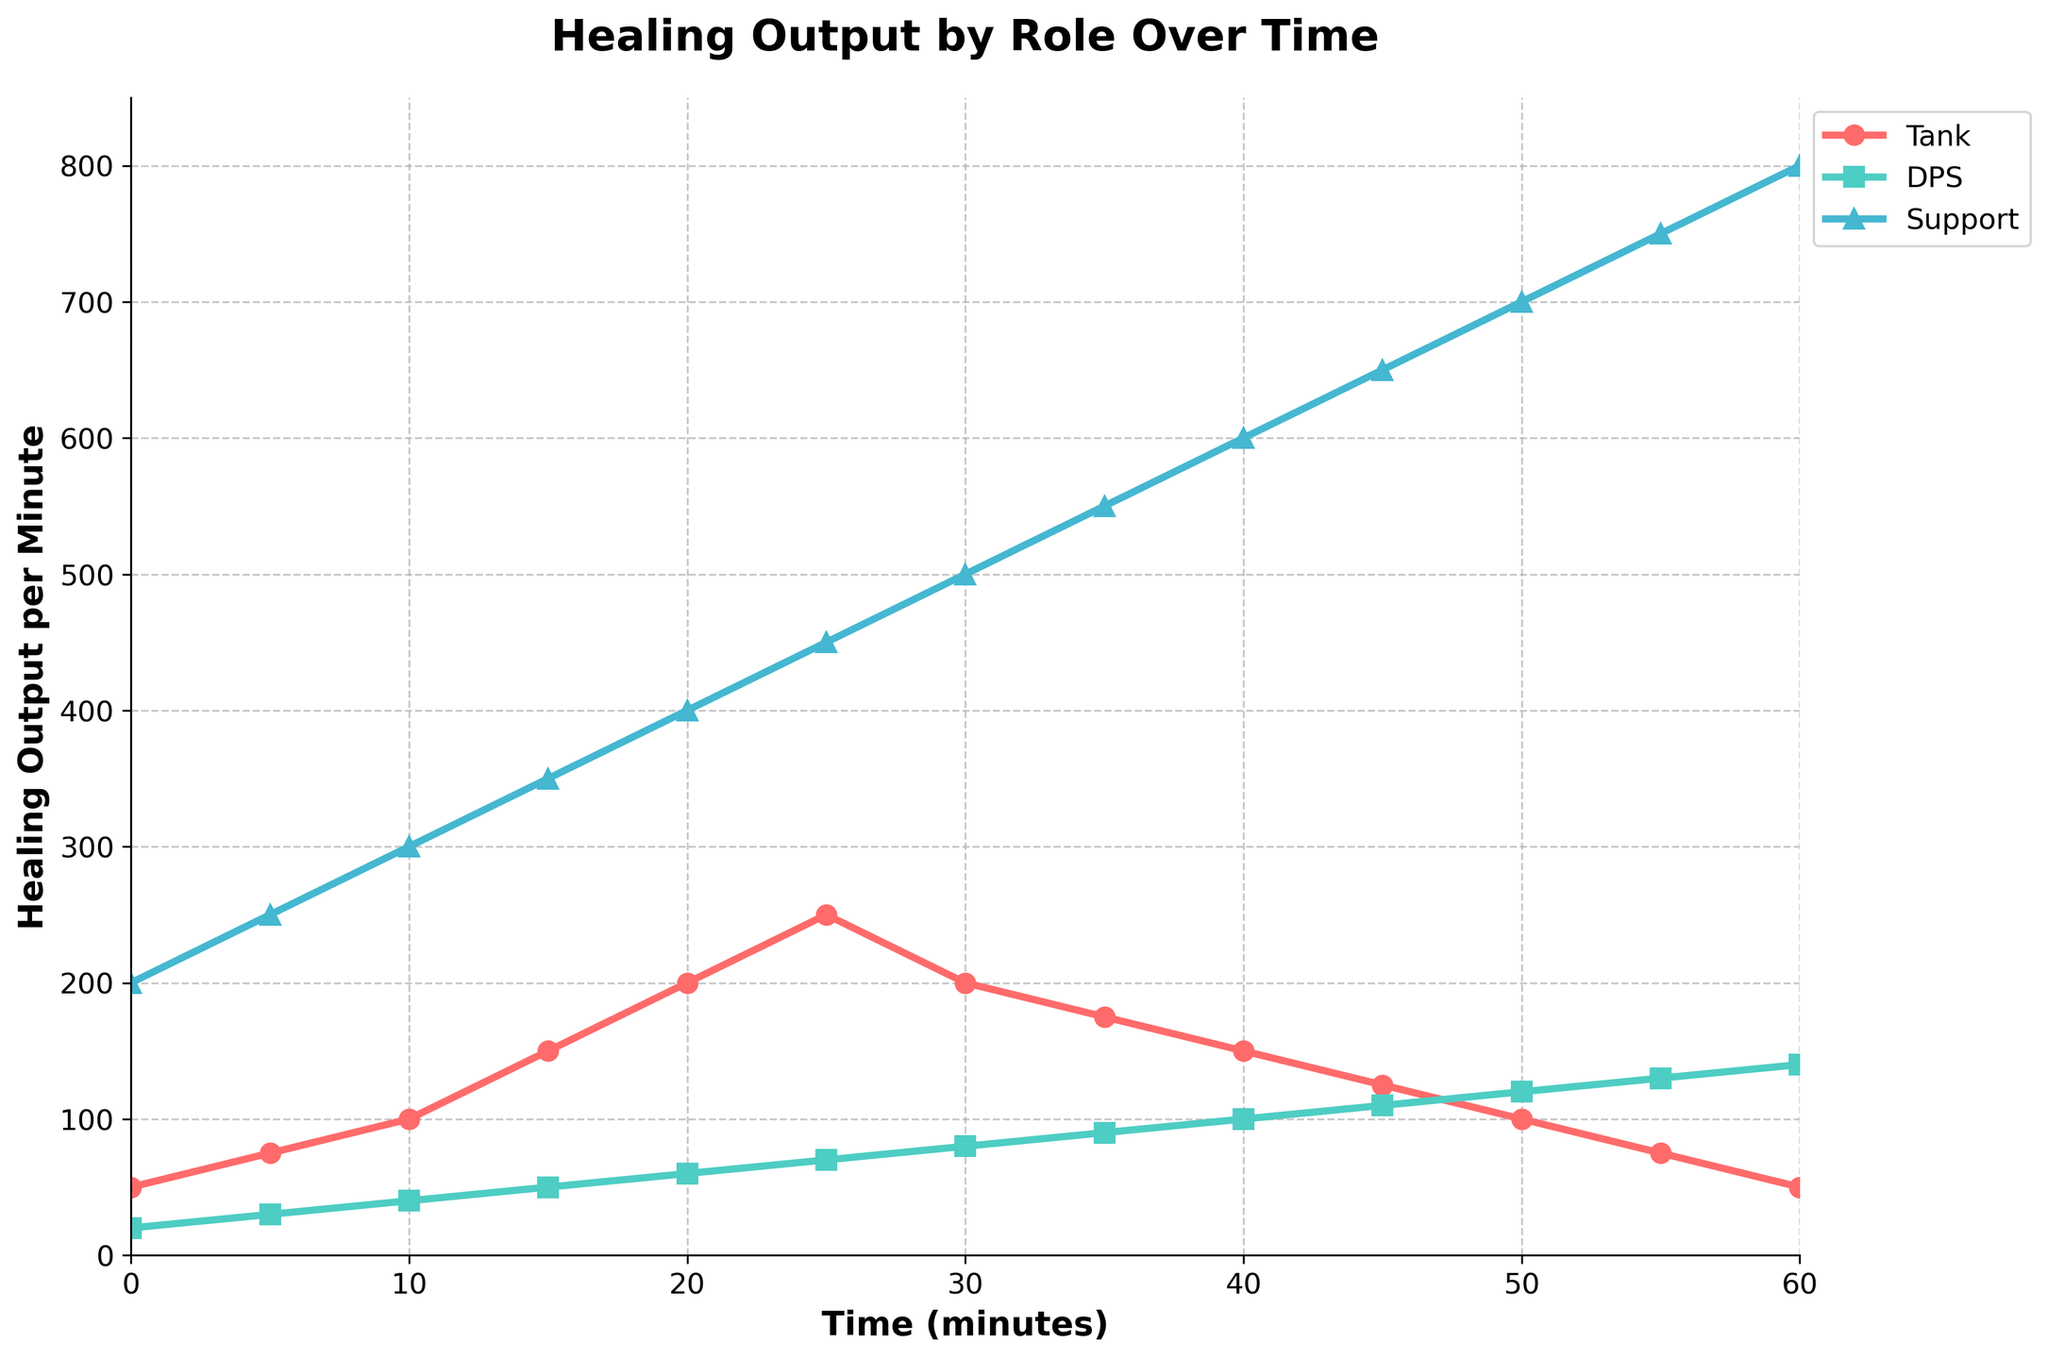How does the healing output of the Tank role change over time? The healing output of the Tank role increases from 50 at the start to a peak of 250 at 25 minutes, then decreases back to 50 by the end of the match.
Answer: It increases, peaks, then decreases Which role has the highest healing output at the 30-minute mark? At the 30-minute mark, the Support role has a healing output of 500, which is higher than both the Tank (200) and DPS (80) roles.
Answer: Support What is the difference in healing output between the Support and Tank roles at the 60-minute mark? At the 60-minute mark, the healing output for Support is 800 and for Tank is 50. The difference is 800 - 50.
Answer: 750 What is the average healing output of the DPS role from 0 to 60 minutes? The healing outputs for the DPS role at each time point are 20, 30, 40, 50, 60, 70, 80, 90, 100, 110, 120, 130, 140. Summing these gives 1040, and there are 13 points. Thus, 1040 / 13.
Answer: 80 How does the healing output for the DPS role compare to the Tank role at the 45-minute mark? At the 45-minute mark, the healing output for DPS is 110 and for Tank is 125. Therefore, DPS has a lower healing output than Tank.
Answer: DPS is lower Which time interval shows the steepest increase in healing output for the Support role? To determine the steepest increase, we look at the differences between consecutive points for the Support role. The steepest increase is between 55 and 60 minutes (750 to 800, a difference of 50).
Answer: 55 to 60 minutes By how much does the healing output of the Tank role change between 25 and 35 minutes? The healing output changes from 250 at 25 minutes to 175 at 35 minutes. The change is 250 - 175.
Answer: 75 At what time does the healing output for the Tank role start to decline? The healing output for the Tank role peaks at 25 minutes with a value of 250, after which it starts to decline.
Answer: 25 minutes Which role maintains a consistent increase in healing output throughout the match? The healing output for the Support role consistently increases from start to end, without any decrease.
Answer: Support How much more healing output does the Support role have compared to the DPS role at the 20-minute mark? At 20 minutes, the healing output for Support is 400 and for DPS is 60. The difference is 400 - 60.
Answer: 340 